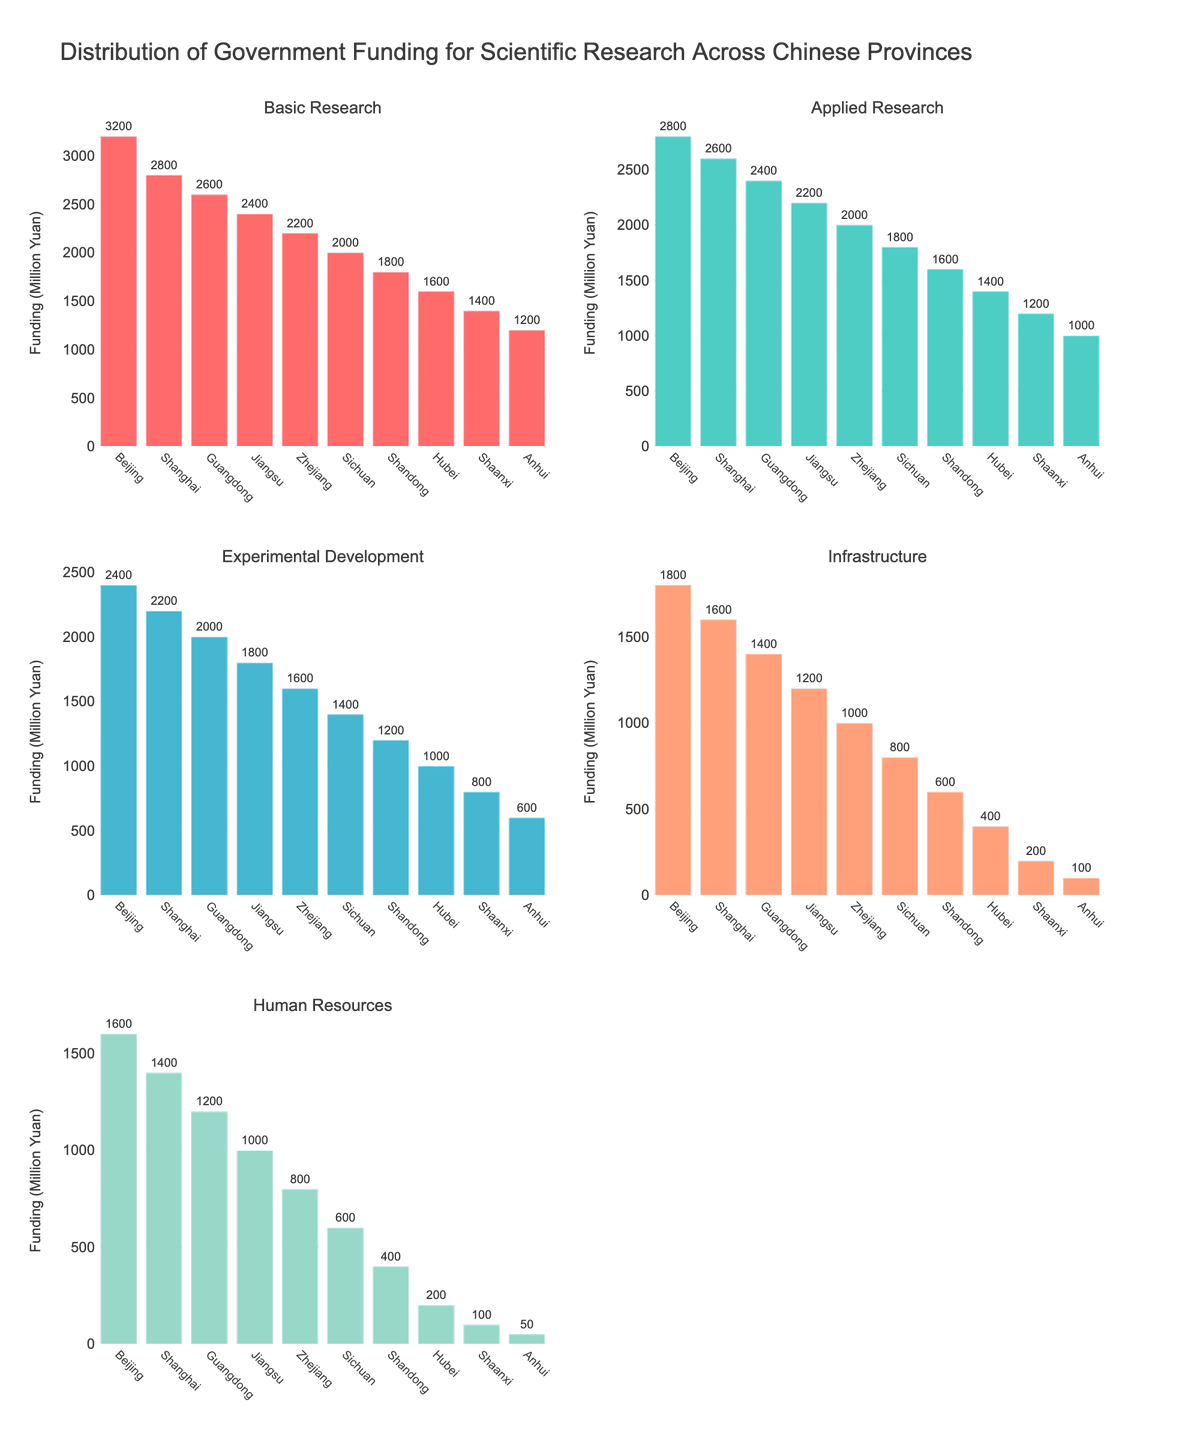What's the title of the figure? The title of the figure is located at the top of the visual. From the provided data, the title should summarize the content of the plot.
Answer: Distribution of Government Funding for Scientific Research Across Chinese Provinces How many categories of funding are displayed in the figure? The subplot titles indicate the number of different categories of funding. By counting them, we arrive at the total number of categories.
Answer: Five Which province has the highest funding for Basic Research? Compare the bars representing Basic Research for each province and identify the one with the highest value.
Answer: Beijing Which category of funding has the least amount allocated overall across all provinces? Sum the funding for each category across all provinces and compare the totals to find the smallest amount.
Answer: Human Resources What is the difference in funding for Applied Research between Beijing and Shaanxi? Look at the bars representing Applied Research for Beijing and Shaanxi and subtract the value for Shaanxi from the value for Beijing.
Answer: 1600 million Yuan What is the average funding for Experimental Development across all provinces? Sum the funding values for Experimental Development from all provinces and divide by the number of provinces.
Answer: 1520 million Yuan Which province has equal funding for two categories of research? Compare the funding values of all categories within each province to check for equality.
Answer: No province has equal funding for two categories Between Sichuan and Jiangsu, which province receives more total funding? Sum the funding amounts for all categories in Sichuan and Jiangsu and compare the totals.
Answer: Jiangsu In which category does Shanghai have the highest rank in terms of funding among the provinces? Compare Shanghai’s funding in each category with all other provinces to determine the highest rank.
Answer: Basic Research What is the total government funding for scientific research in Shandong across all categories? Sum the funding values for all five categories in the province of Shandong.
Answer: 4600 million Yuan 